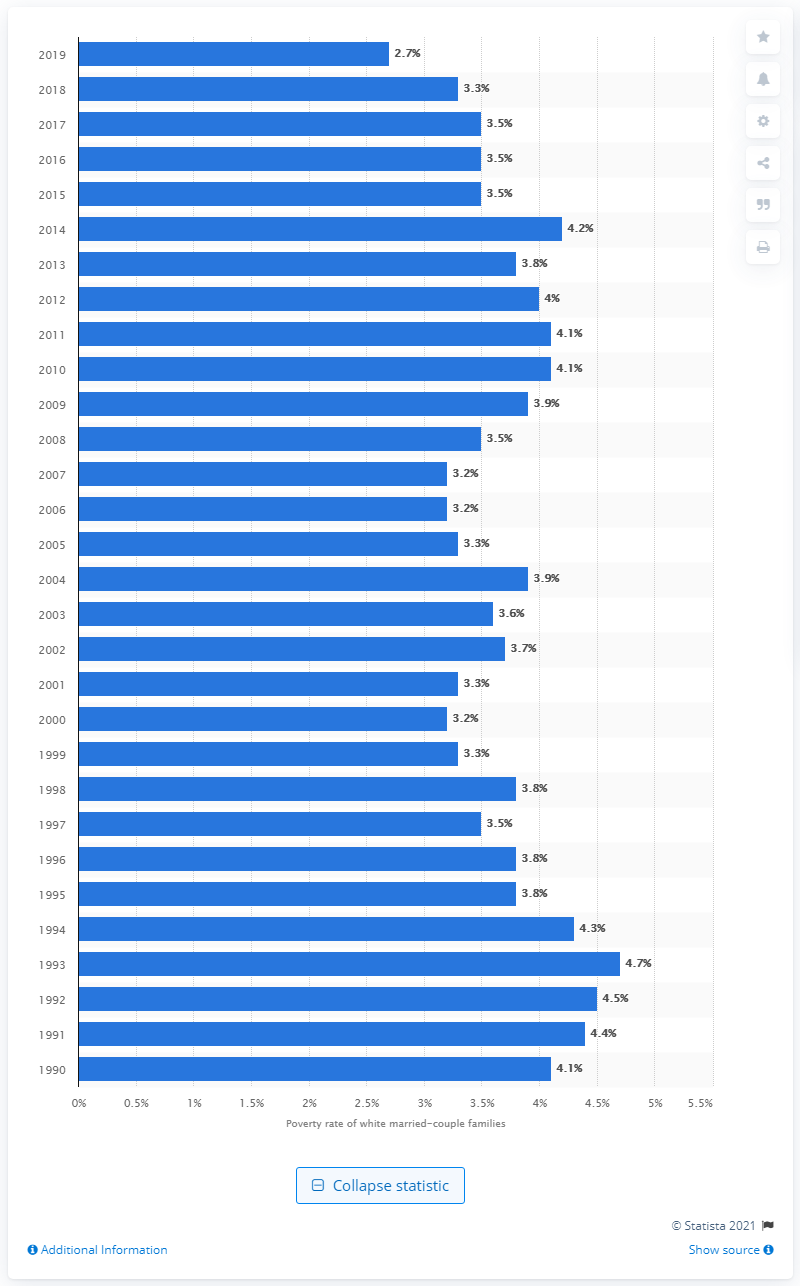Mention a couple of crucial points in this snapshot. In 2019, approximately 2.7% of white, non-Hispanic married couple families lived below the poverty level. 